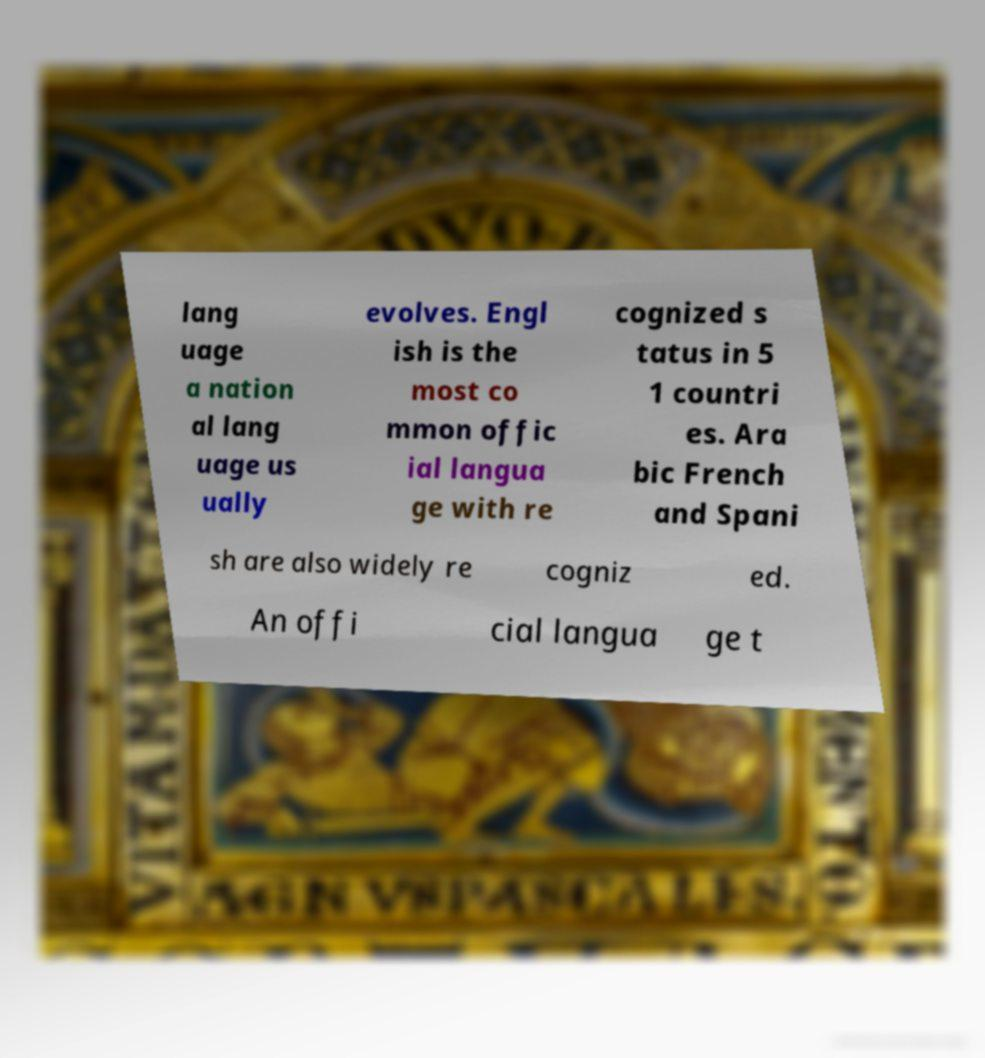There's text embedded in this image that I need extracted. Can you transcribe it verbatim? lang uage a nation al lang uage us ually evolves. Engl ish is the most co mmon offic ial langua ge with re cognized s tatus in 5 1 countri es. Ara bic French and Spani sh are also widely re cogniz ed. An offi cial langua ge t 